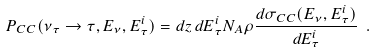Convert formula to latex. <formula><loc_0><loc_0><loc_500><loc_500>P _ { C C } ( \nu _ { \tau } \rightarrow \tau , E _ { \nu } , E _ { \tau } ^ { i } ) = { d z \, d E _ { \tau } ^ { i } } N _ { A } \rho \frac { d \sigma _ { C C } ( E _ { \nu } , E _ { \tau } ^ { i } ) } { d E _ { \tau } ^ { i } } \ .</formula> 